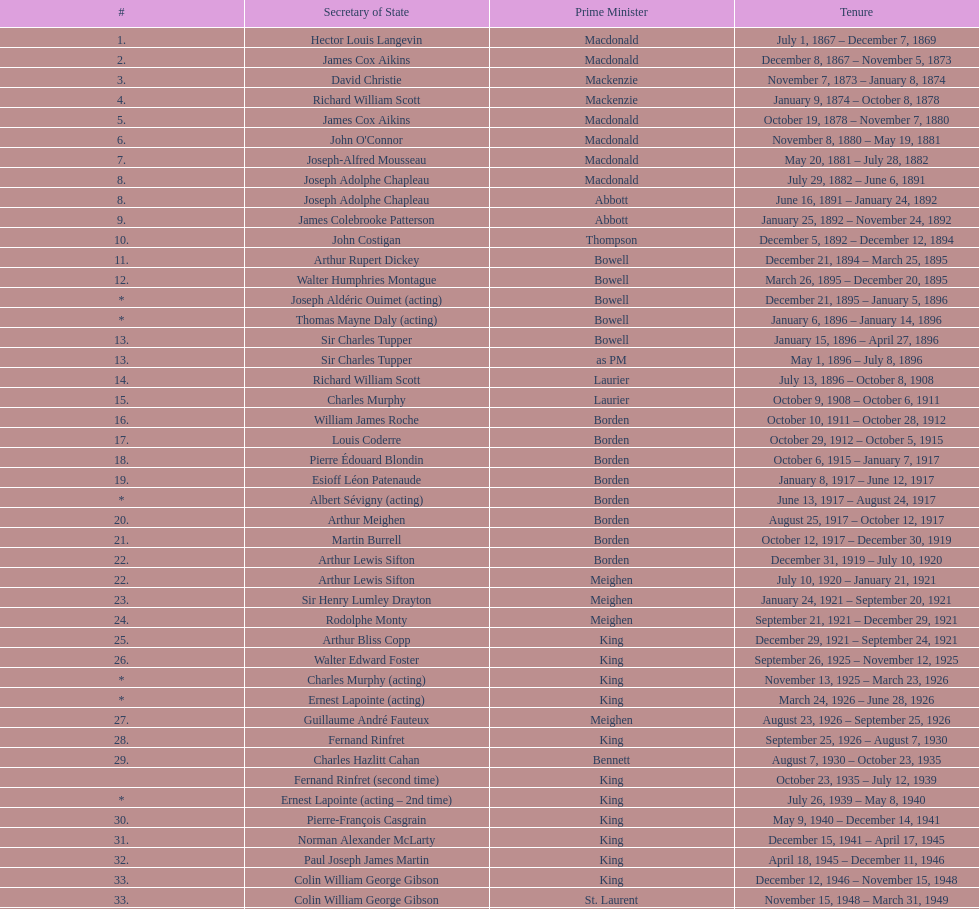Which secretary of state came after jack pkckersgill? Roch Pinard. 